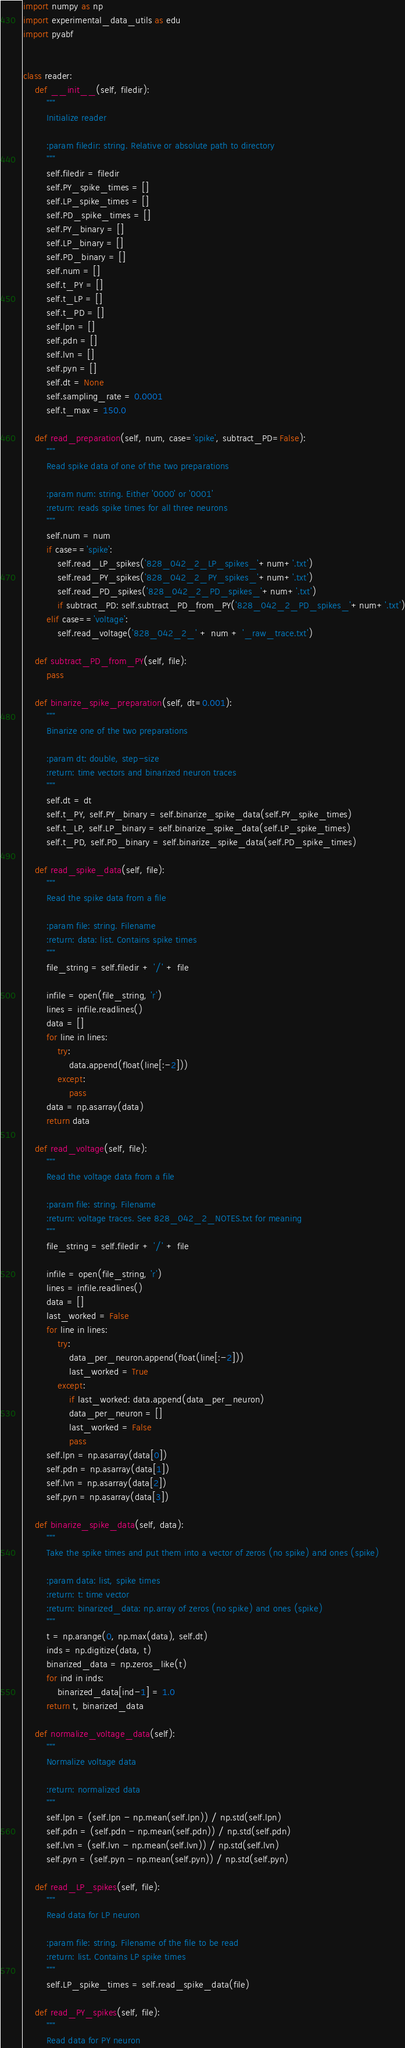Convert code to text. <code><loc_0><loc_0><loc_500><loc_500><_Python_>import numpy as np
import experimental_data_utils as edu
import pyabf


class reader:
    def __init__(self, filedir):
        """
        Initialize reader

        :param filedir: string. Relative or absolute path to directory
        """
        self.filedir = filedir
        self.PY_spike_times = []
        self.LP_spike_times = []
        self.PD_spike_times = []
        self.PY_binary = []
        self.LP_binary = []
        self.PD_binary = []
        self.num = []
        self.t_PY = []
        self.t_LP = []
        self.t_PD = []
        self.lpn = []
        self.pdn = []
        self.lvn = []
        self.pyn = []
        self.dt = None
        self.sampling_rate = 0.0001
        self.t_max = 150.0

    def read_preparation(self, num, case='spike', subtract_PD=False):
        """
        Read spike data of one of the two preparations

        :param num: string. Either '0000' or '0001'
        :return: reads spike times for all three neurons
        """
        self.num = num
        if case=='spike':
            self.read_LP_spikes('828_042_2_LP_spikes_'+num+'.txt')
            self.read_PY_spikes('828_042_2_PY_spikes_'+num+'.txt')
            self.read_PD_spikes('828_042_2_PD_spikes_'+num+'.txt')
            if subtract_PD: self.subtract_PD_from_PY('828_042_2_PD_spikes_'+num+'.txt')
        elif case=='voltage':
            self.read_voltage('828_042_2_' + num + '_raw_trace.txt')

    def subtract_PD_from_PY(self, file):
        pass

    def binarize_spike_preparation(self, dt=0.001):
        """
        Binarize one of the two preparations

        :param dt: double, step-size
        :return: time vectors and binarized neuron traces
        """
        self.dt = dt
        self.t_PY, self.PY_binary = self.binarize_spike_data(self.PY_spike_times)
        self.t_LP, self.LP_binary = self.binarize_spike_data(self.LP_spike_times)
        self.t_PD, self.PD_binary = self.binarize_spike_data(self.PD_spike_times)

    def read_spike_data(self, file):
        """
        Read the spike data from a file

        :param file: string. Filename
        :return: data: list. Contains spike times
        """
        file_string = self.filedir + '/' + file

        infile = open(file_string, 'r')
        lines = infile.readlines()
        data = []
        for line in lines:
            try:
                data.append(float(line[:-2]))
            except:
                pass
        data = np.asarray(data)
        return data

    def read_voltage(self, file):
        """
        Read the voltage data from a file

        :param file: string. Filename
        :return: voltage traces. See 828_042_2_NOTES.txt for meaning
        """
        file_string = self.filedir + '/' + file

        infile = open(file_string, 'r')
        lines = infile.readlines()
        data = []
        last_worked = False
        for line in lines:
            try:
                data_per_neuron.append(float(line[:-2]))
                last_worked = True
            except:
                if last_worked: data.append(data_per_neuron)
                data_per_neuron = []
                last_worked = False
                pass
        self.lpn = np.asarray(data[0])
        self.pdn = np.asarray(data[1])
        self.lvn = np.asarray(data[2])
        self.pyn = np.asarray(data[3])

    def binarize_spike_data(self, data):
        """
        Take the spike times and put them into a vector of zeros (no spike) and ones (spike)

        :param data: list, spike times
        :return: t: time vector
        :return: binarized_data: np.array of zeros (no spike) and ones (spike)
        """
        t = np.arange(0, np.max(data), self.dt)
        inds = np.digitize(data, t)
        binarized_data = np.zeros_like(t)
        for ind in inds:
            binarized_data[ind-1] = 1.0
        return t, binarized_data

    def normalize_voltage_data(self):
        """
        Normalize voltage data

        :return: normalized data
        """
        self.lpn = (self.lpn - np.mean(self.lpn)) / np.std(self.lpn)
        self.pdn = (self.pdn - np.mean(self.pdn)) / np.std(self.pdn)
        self.lvn = (self.lvn - np.mean(self.lvn)) / np.std(self.lvn)
        self.pyn = (self.pyn - np.mean(self.pyn)) / np.std(self.pyn)

    def read_LP_spikes(self, file):
        """
        Read data for LP neuron

        :param file: string. Filename of the file to be read
        :return: list. Contains LP spike times
        """
        self.LP_spike_times = self.read_spike_data(file)

    def read_PY_spikes(self, file):
        """
        Read data for PY neuron
</code> 